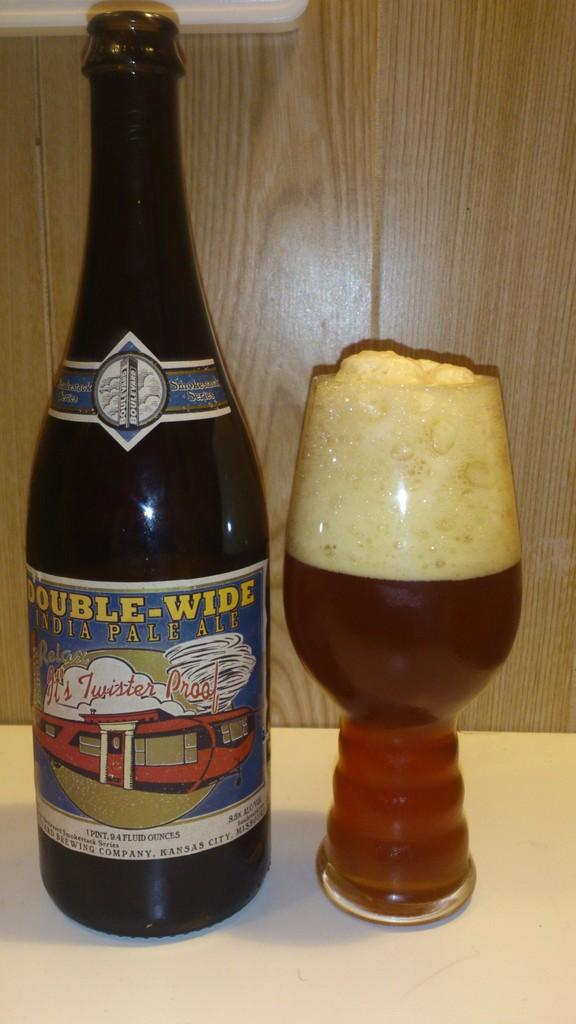<image>
Provide a brief description of the given image. A very full and foamy snifter with a ridged base next to to a bottle of Double Wide India Pale Ale. 